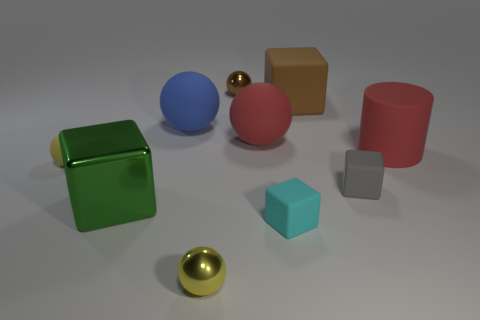Is the large shiny cube the same color as the cylinder? no 